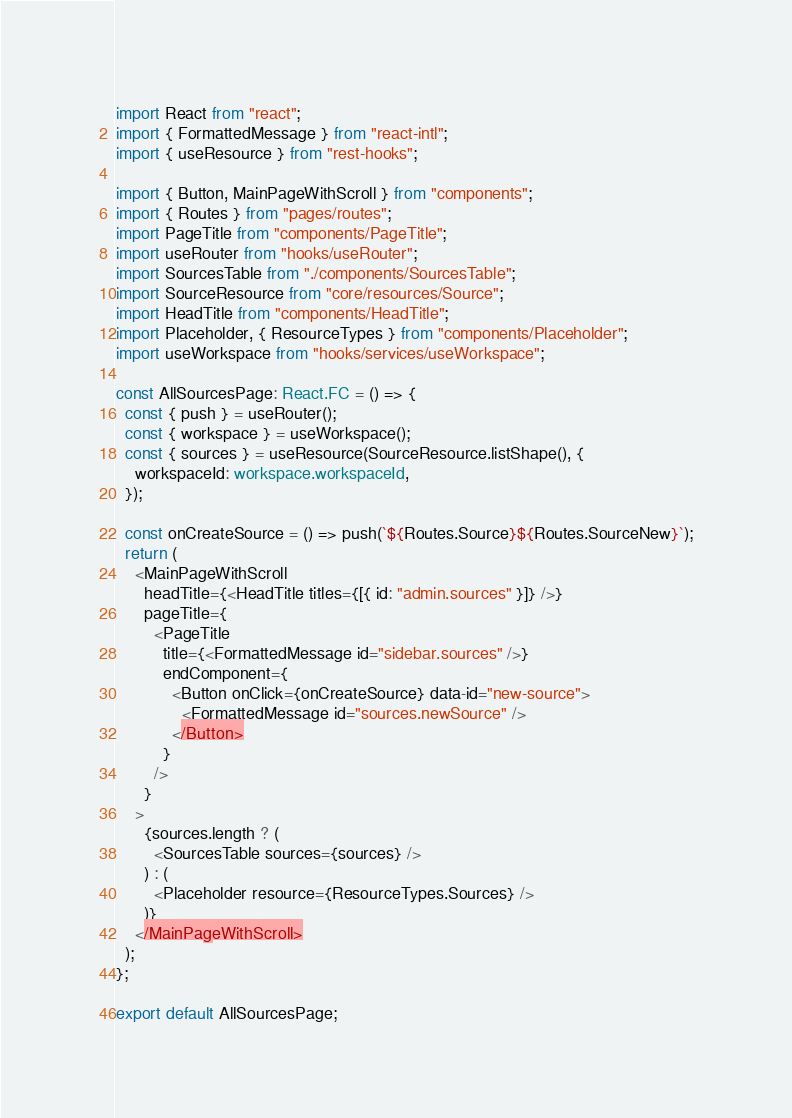<code> <loc_0><loc_0><loc_500><loc_500><_TypeScript_>import React from "react";
import { FormattedMessage } from "react-intl";
import { useResource } from "rest-hooks";

import { Button, MainPageWithScroll } from "components";
import { Routes } from "pages/routes";
import PageTitle from "components/PageTitle";
import useRouter from "hooks/useRouter";
import SourcesTable from "./components/SourcesTable";
import SourceResource from "core/resources/Source";
import HeadTitle from "components/HeadTitle";
import Placeholder, { ResourceTypes } from "components/Placeholder";
import useWorkspace from "hooks/services/useWorkspace";

const AllSourcesPage: React.FC = () => {
  const { push } = useRouter();
  const { workspace } = useWorkspace();
  const { sources } = useResource(SourceResource.listShape(), {
    workspaceId: workspace.workspaceId,
  });

  const onCreateSource = () => push(`${Routes.Source}${Routes.SourceNew}`);
  return (
    <MainPageWithScroll
      headTitle={<HeadTitle titles={[{ id: "admin.sources" }]} />}
      pageTitle={
        <PageTitle
          title={<FormattedMessage id="sidebar.sources" />}
          endComponent={
            <Button onClick={onCreateSource} data-id="new-source">
              <FormattedMessage id="sources.newSource" />
            </Button>
          }
        />
      }
    >
      {sources.length ? (
        <SourcesTable sources={sources} />
      ) : (
        <Placeholder resource={ResourceTypes.Sources} />
      )}
    </MainPageWithScroll>
  );
};

export default AllSourcesPage;
</code> 